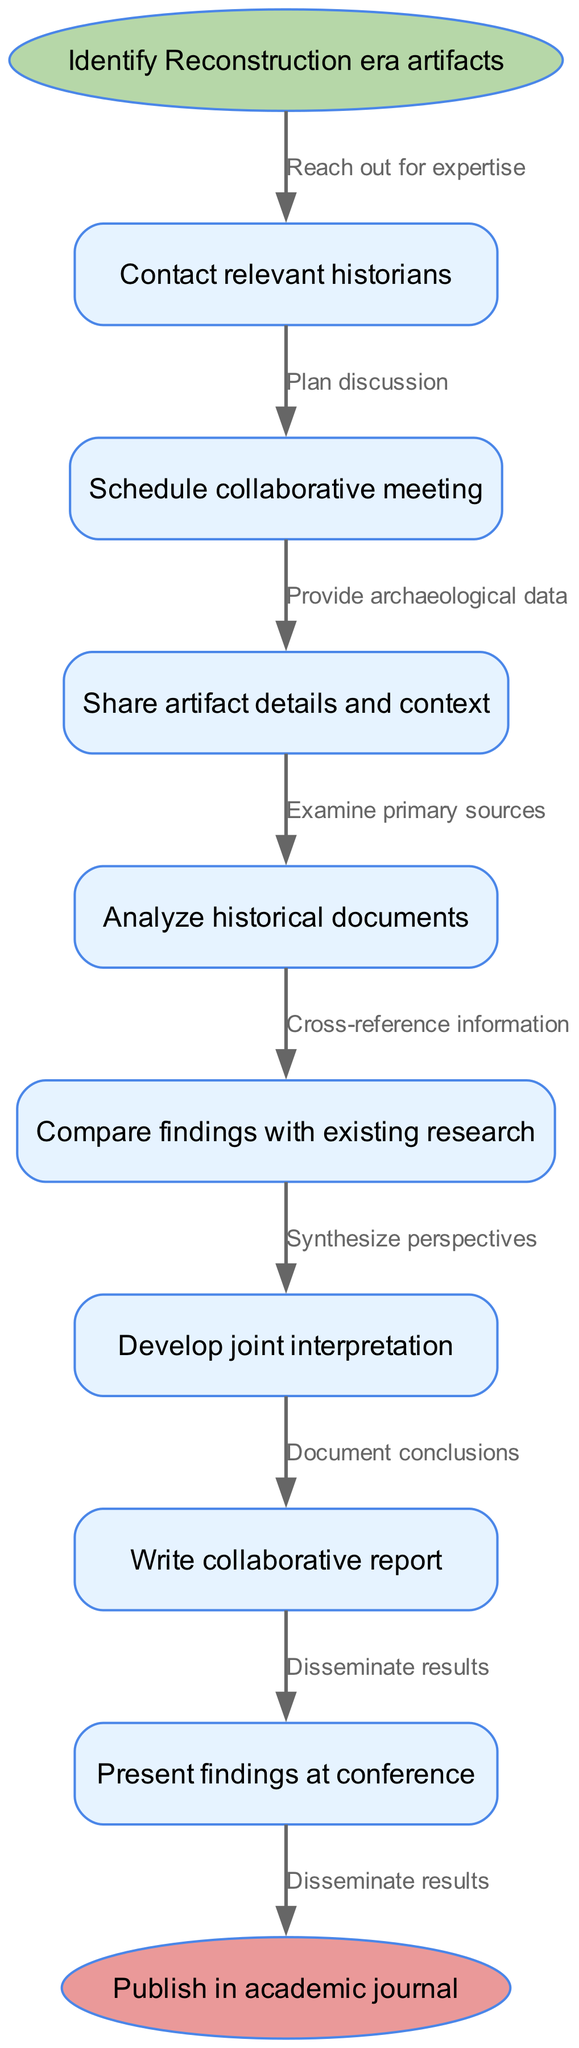What is the starting point of the diagram? The starting point, indicated by the 'start' node, is 'Identify Reconstruction era artifacts'.
Answer: Identify Reconstruction era artifacts How many process nodes are there in total? There are eight process nodes in total, including the start and end nodes. The process nodes are the ones listed between the start and end nodes in the diagram.
Answer: 8 What is the last step before publishing the report? The last step before publishing the report, which is indicated by the process right before the end node, is 'Write collaborative report'.
Answer: Write collaborative report Which node follows 'Share artifact details and context'? The node that follows 'Share artifact details and context' is 'Analyze historical documents', as shown by the directed edge connecting those two nodes.
Answer: Analyze historical documents How many edges connect the process nodes? There are seven edges connecting the process nodes, each representing a relationship between two consecutive nodes in the flow.
Answer: 7 What type of communication happens before 'Schedule collaborative meeting'? The type of communication that happens before 'Schedule collaborative meeting' is 'Contact relevant historians', which indicates reaching out for expertise.
Answer: Contact relevant historians What is the relationship between 'Analyze historical documents' and 'Develop joint interpretation'? The relationship is that 'Analyze historical documents' leads to 'Develop joint interpretation', indicating a sequential process where analyzing leads to development of an interpretation.
Answer: Sequential process What is the final outcome of the collaborative research process? The final outcome of the collaborative research process is indicated by the end node, which states 'Publish in academic journal'.
Answer: Publish in academic journal 